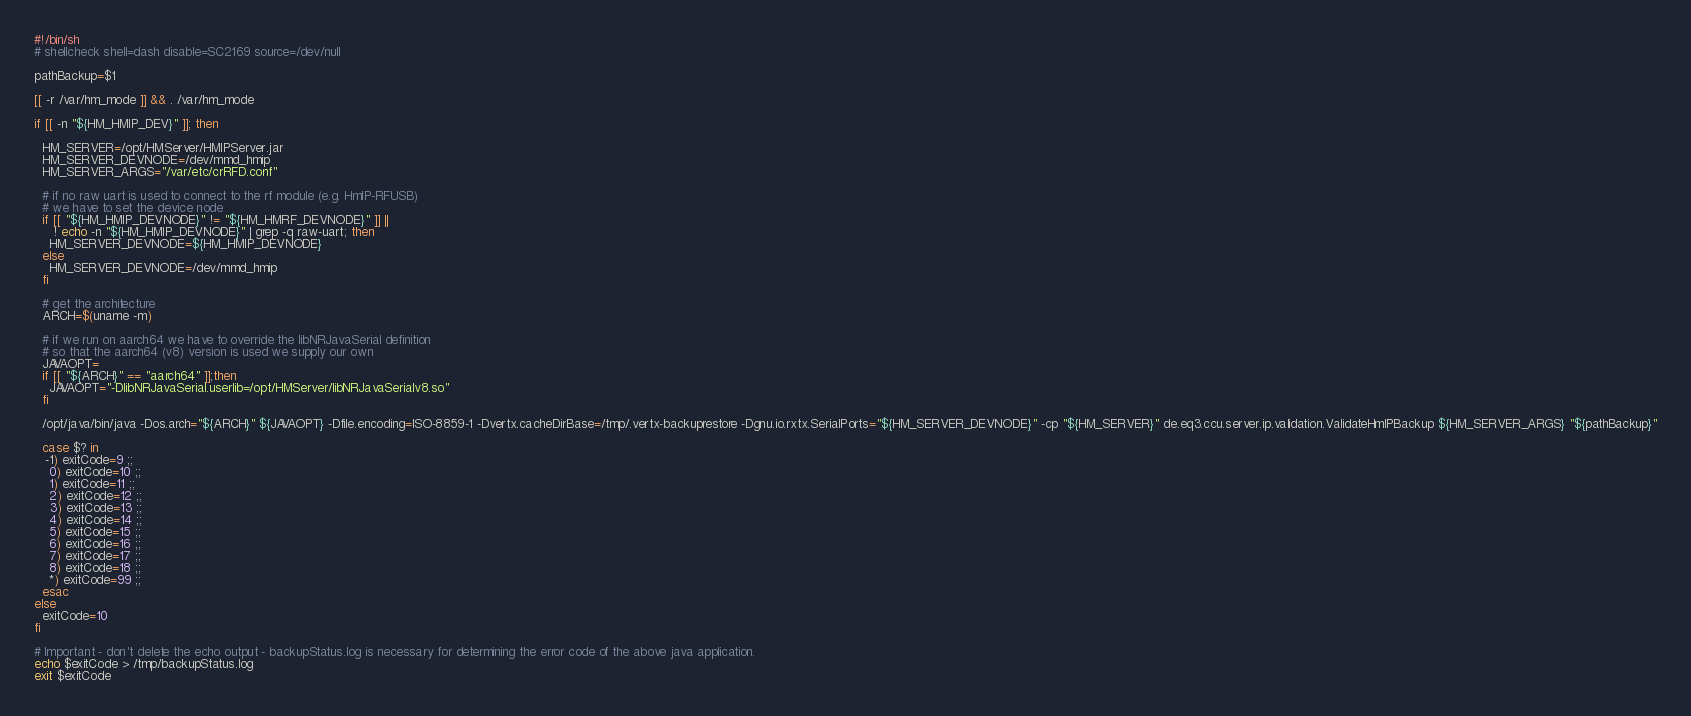Convert code to text. <code><loc_0><loc_0><loc_500><loc_500><_Bash_>#!/bin/sh
# shellcheck shell=dash disable=SC2169 source=/dev/null

pathBackup=$1

[[ -r /var/hm_mode ]] && . /var/hm_mode

if [[ -n "${HM_HMIP_DEV}" ]]; then

  HM_SERVER=/opt/HMServer/HMIPServer.jar
  HM_SERVER_DEVNODE=/dev/mmd_hmip
  HM_SERVER_ARGS="/var/etc/crRFD.conf"

  # if no raw uart is used to connect to the rf module (e.g. HmIP-RFUSB)
  # we have to set the device node
  if [[ "${HM_HMIP_DEVNODE}" != "${HM_HMRF_DEVNODE}" ]] ||
     ! echo -n "${HM_HMIP_DEVNODE}" | grep -q raw-uart; then
    HM_SERVER_DEVNODE=${HM_HMIP_DEVNODE}
  else
    HM_SERVER_DEVNODE=/dev/mmd_hmip
  fi

  # get the architecture
  ARCH=$(uname -m)

  # if we run on aarch64 we have to override the libNRJavaSerial definition
  # so that the aarch64 (v8) version is used we supply our own
  JAVAOPT=
  if [[ "${ARCH}" == "aarch64" ]];then
    JAVAOPT="-DlibNRJavaSerial.userlib=/opt/HMServer/libNRJavaSerialv8.so"
  fi

  /opt/java/bin/java -Dos.arch="${ARCH}" ${JAVAOPT} -Dfile.encoding=ISO-8859-1 -Dvertx.cacheDirBase=/tmp/.vertx-backuprestore -Dgnu.io.rxtx.SerialPorts="${HM_SERVER_DEVNODE}" -cp "${HM_SERVER}" de.eq3.ccu.server.ip.validation.ValidateHmIPBackup ${HM_SERVER_ARGS} "${pathBackup}"

  case $? in
   -1) exitCode=9 ;;
    0) exitCode=10 ;;
    1) exitCode=11 ;;
    2) exitCode=12 ;;
    3) exitCode=13 ;;
    4) exitCode=14 ;;
    5) exitCode=15 ;;
    6) exitCode=16 ;;
    7) exitCode=17 ;;
    8) exitCode=18 ;;
    *) exitCode=99 ;;
  esac
else
  exitCode=10
fi

# Important - don't delete the echo output - backupStatus.log is necessary for determining the error code of the above java application.
echo $exitCode > /tmp/backupStatus.log
exit $exitCode
</code> 